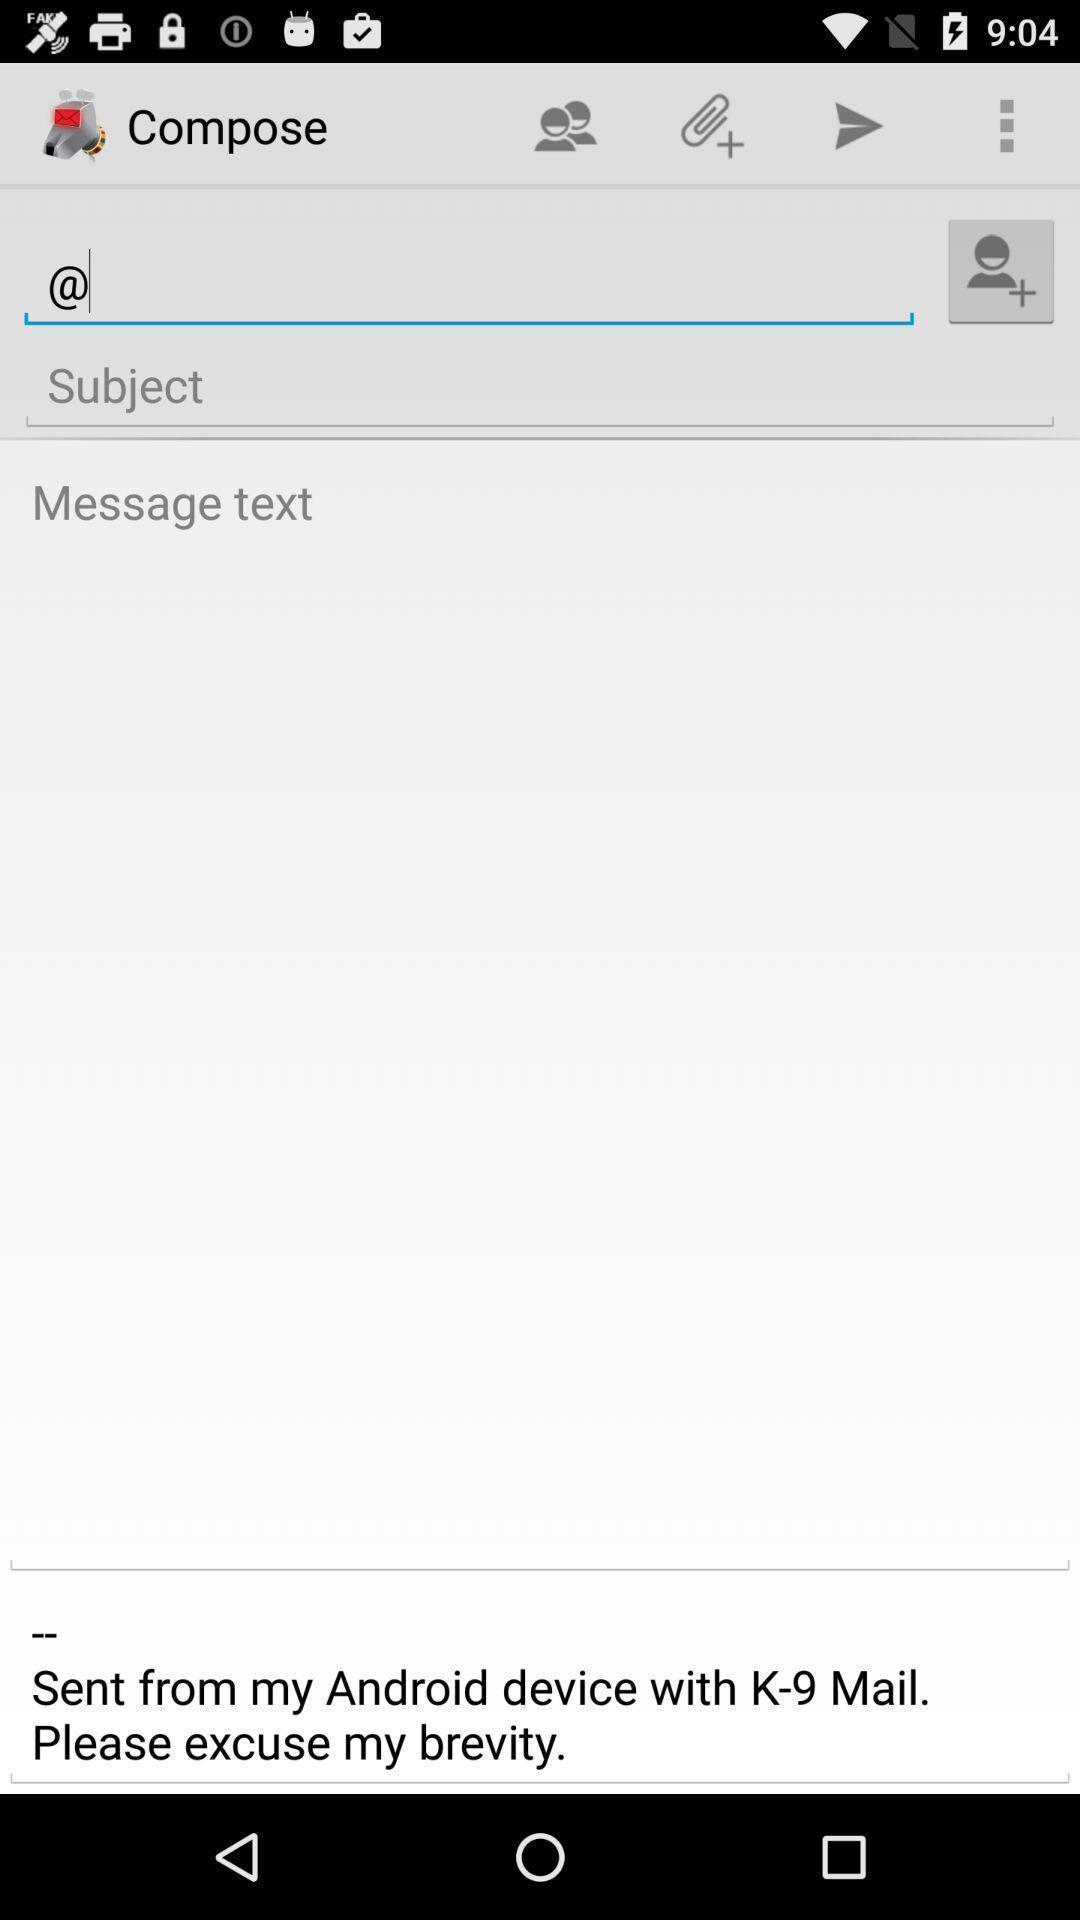Tell me what you see in this picture. Type the person 's account address to send the mail. 